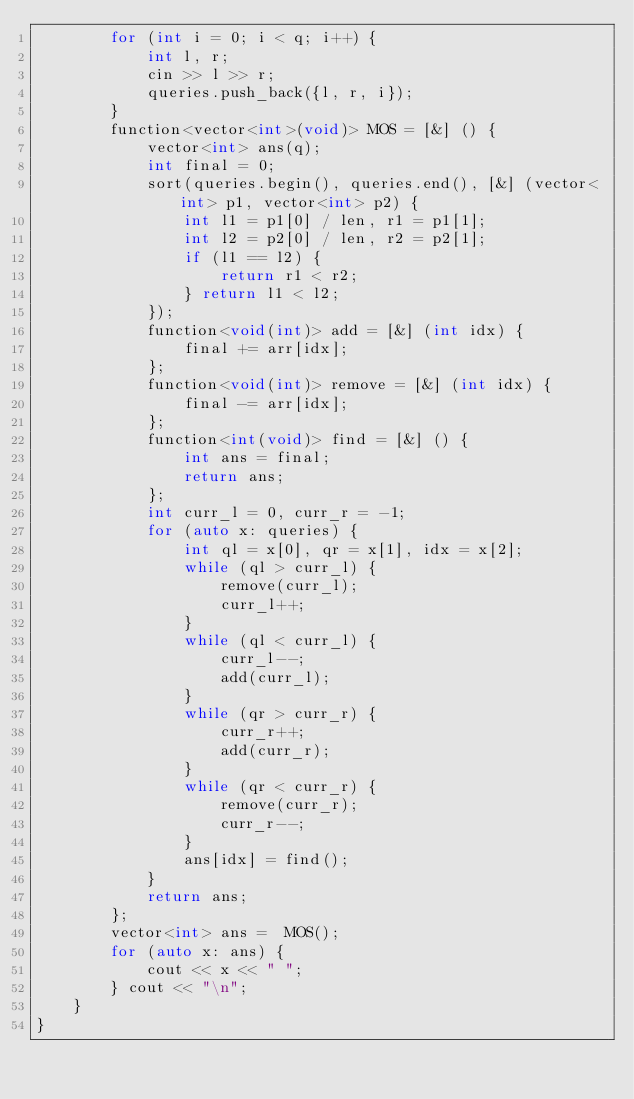<code> <loc_0><loc_0><loc_500><loc_500><_C++_>        for (int i = 0; i < q; i++) {
            int l, r;
            cin >> l >> r;
            queries.push_back({l, r, i});
        }
        function<vector<int>(void)> MOS = [&] () {
            vector<int> ans(q);
            int final = 0;
            sort(queries.begin(), queries.end(), [&] (vector<int> p1, vector<int> p2) {
                int l1 = p1[0] / len, r1 = p1[1];
                int l2 = p2[0] / len, r2 = p2[1];
                if (l1 == l2) {
                    return r1 < r2;
                } return l1 < l2;
            });
            function<void(int)> add = [&] (int idx) {
                final += arr[idx];
            };
            function<void(int)> remove = [&] (int idx) {
                final -= arr[idx];
            };
            function<int(void)> find = [&] () {
                int ans = final;
                return ans;
            };
            int curr_l = 0, curr_r = -1;
            for (auto x: queries) {
                int ql = x[0], qr = x[1], idx = x[2];
                while (ql > curr_l) {
                    remove(curr_l);
                    curr_l++;
                }
                while (ql < curr_l) {
                    curr_l--;
                    add(curr_l);
                }
                while (qr > curr_r) {
                    curr_r++;
                    add(curr_r);
                }
                while (qr < curr_r) {
                    remove(curr_r);
                    curr_r--;
                }
                ans[idx] = find();
            }
            return ans;
        };
        vector<int> ans =  MOS();
        for (auto x: ans) {
            cout << x << " ";
        } cout << "\n";
    }
}</code> 